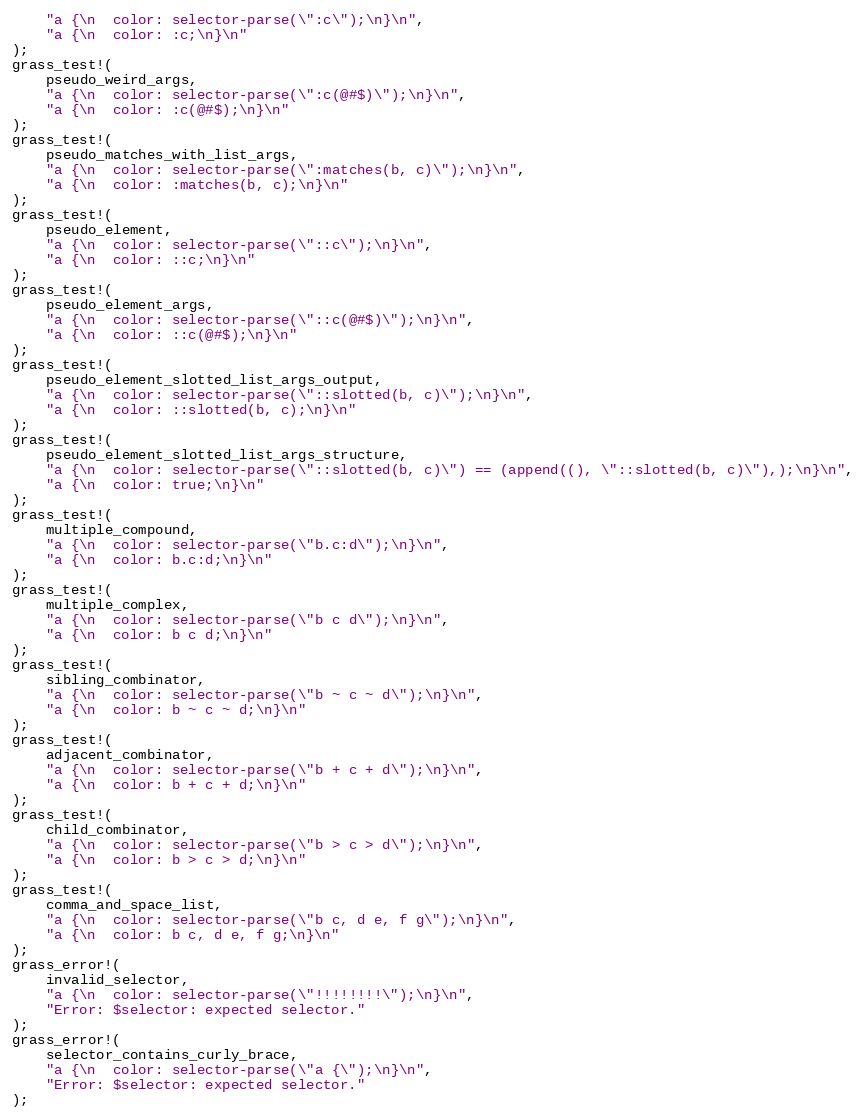Convert code to text. <code><loc_0><loc_0><loc_500><loc_500><_Rust_>    "a {\n  color: selector-parse(\":c\");\n}\n",
    "a {\n  color: :c;\n}\n"
);
grass_test!(
    pseudo_weird_args,
    "a {\n  color: selector-parse(\":c(@#$)\");\n}\n",
    "a {\n  color: :c(@#$);\n}\n"
);
grass_test!(
    pseudo_matches_with_list_args,
    "a {\n  color: selector-parse(\":matches(b, c)\");\n}\n",
    "a {\n  color: :matches(b, c);\n}\n"
);
grass_test!(
    pseudo_element,
    "a {\n  color: selector-parse(\"::c\");\n}\n",
    "a {\n  color: ::c;\n}\n"
);
grass_test!(
    pseudo_element_args,
    "a {\n  color: selector-parse(\"::c(@#$)\");\n}\n",
    "a {\n  color: ::c(@#$);\n}\n"
);
grass_test!(
    pseudo_element_slotted_list_args_output,
    "a {\n  color: selector-parse(\"::slotted(b, c)\");\n}\n",
    "a {\n  color: ::slotted(b, c);\n}\n"
);
grass_test!(
    pseudo_element_slotted_list_args_structure,
    "a {\n  color: selector-parse(\"::slotted(b, c)\") == (append((), \"::slotted(b, c)\"),);\n}\n",
    "a {\n  color: true;\n}\n"
);
grass_test!(
    multiple_compound,
    "a {\n  color: selector-parse(\"b.c:d\");\n}\n",
    "a {\n  color: b.c:d;\n}\n"
);
grass_test!(
    multiple_complex,
    "a {\n  color: selector-parse(\"b c d\");\n}\n",
    "a {\n  color: b c d;\n}\n"
);
grass_test!(
    sibling_combinator,
    "a {\n  color: selector-parse(\"b ~ c ~ d\");\n}\n",
    "a {\n  color: b ~ c ~ d;\n}\n"
);
grass_test!(
    adjacent_combinator,
    "a {\n  color: selector-parse(\"b + c + d\");\n}\n",
    "a {\n  color: b + c + d;\n}\n"
);
grass_test!(
    child_combinator,
    "a {\n  color: selector-parse(\"b > c > d\");\n}\n",
    "a {\n  color: b > c > d;\n}\n"
);
grass_test!(
    comma_and_space_list,
    "a {\n  color: selector-parse(\"b c, d e, f g\");\n}\n",
    "a {\n  color: b c, d e, f g;\n}\n"
);
grass_error!(
    invalid_selector,
    "a {\n  color: selector-parse(\"!!!!!!!!\");\n}\n",
    "Error: $selector: expected selector."
);
grass_error!(
    selector_contains_curly_brace,
    "a {\n  color: selector-parse(\"a {\");\n}\n",
    "Error: $selector: expected selector."
);
</code> 